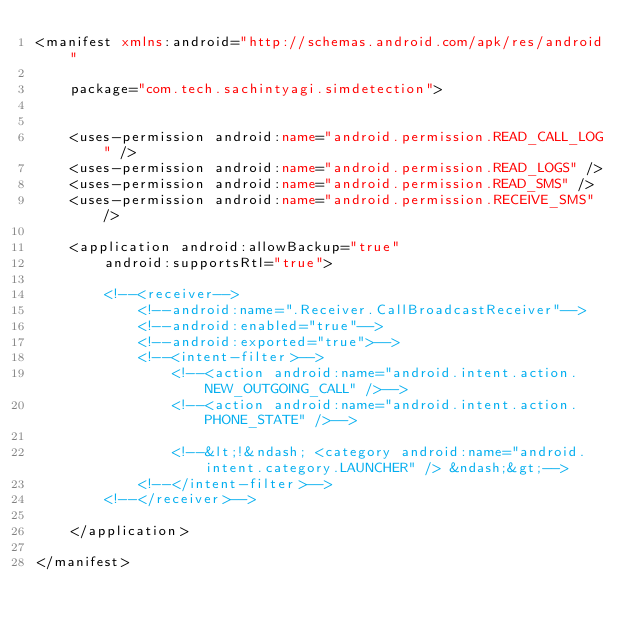Convert code to text. <code><loc_0><loc_0><loc_500><loc_500><_XML_><manifest xmlns:android="http://schemas.android.com/apk/res/android"

    package="com.tech.sachintyagi.simdetection">


    <uses-permission android:name="android.permission.READ_CALL_LOG" />
    <uses-permission android:name="android.permission.READ_LOGS" />
    <uses-permission android:name="android.permission.READ_SMS" />
    <uses-permission android:name="android.permission.RECEIVE_SMS" />

    <application android:allowBackup="true"
        android:supportsRtl="true">

        <!--<receiver-->
            <!--android:name=".Receiver.CallBroadcastReceiver"-->
            <!--android:enabled="true"-->
            <!--android:exported="true">-->
            <!--<intent-filter>-->
                <!--<action android:name="android.intent.action.NEW_OUTGOING_CALL" />-->
                <!--<action android:name="android.intent.action.PHONE_STATE" />-->

                <!--&lt;!&ndash; <category android:name="android.intent.category.LAUNCHER" /> &ndash;&gt;-->
            <!--</intent-filter>-->
        <!--</receiver>-->

    </application>

</manifest>
</code> 